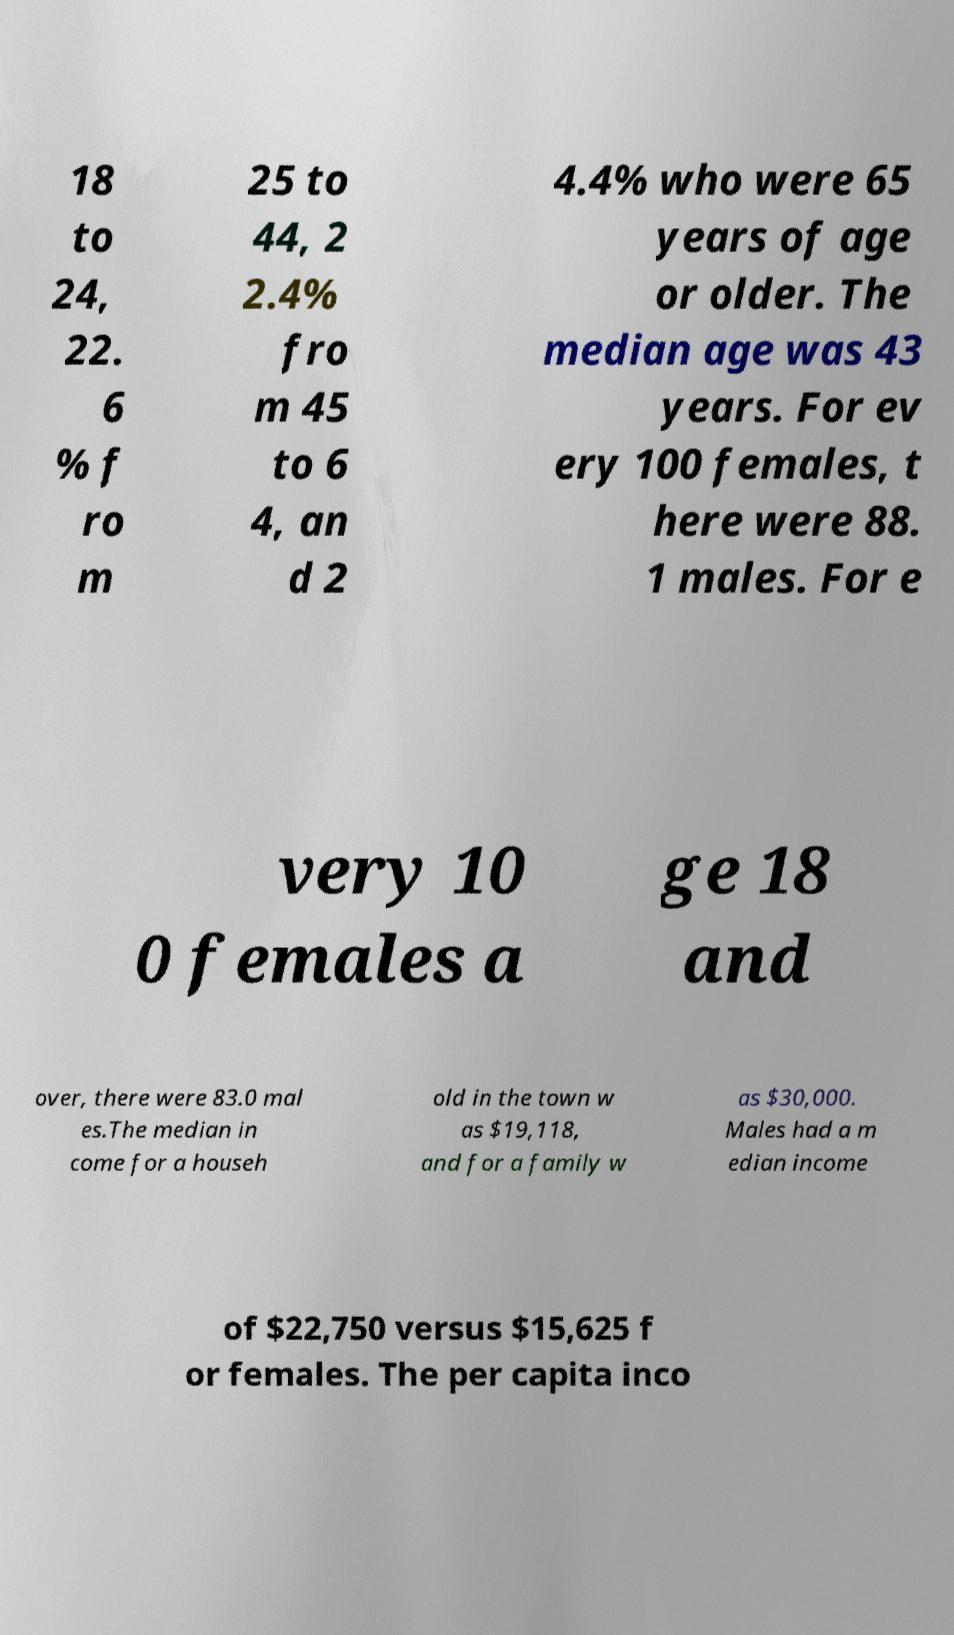Please identify and transcribe the text found in this image. 18 to 24, 22. 6 % f ro m 25 to 44, 2 2.4% fro m 45 to 6 4, an d 2 4.4% who were 65 years of age or older. The median age was 43 years. For ev ery 100 females, t here were 88. 1 males. For e very 10 0 females a ge 18 and over, there were 83.0 mal es.The median in come for a househ old in the town w as $19,118, and for a family w as $30,000. Males had a m edian income of $22,750 versus $15,625 f or females. The per capita inco 